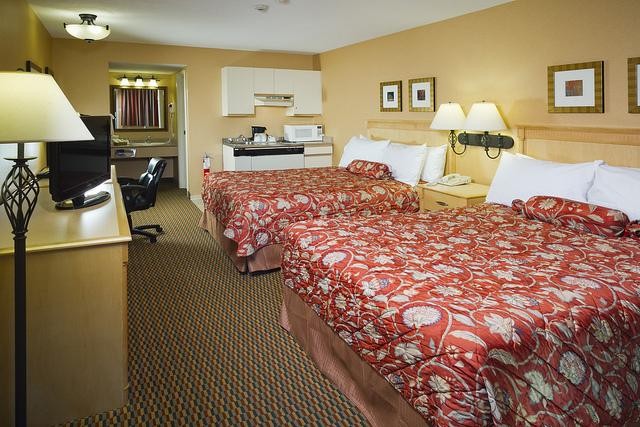Who would stay in this room? Please explain your reasoning. traveler. A room with two beds and somewhat commercial carpet can be seen. there are no personal items or picture frames around the room. 